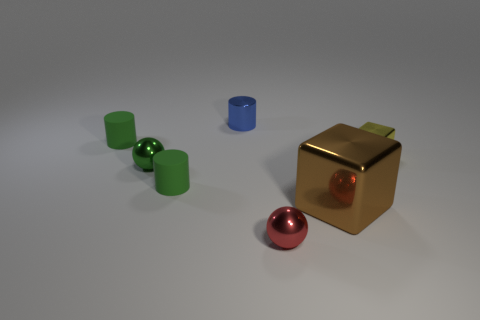Can you describe the attributes of the cube in the center? The cube in the center has a smooth and reflective gold-colored surface, suggesting that it may be made of a polished metal or a metallic paint. Its surface is shiny, reflecting the light and surrounding objects faintly, with a red sphere lodged in an indentation on its closest face. 